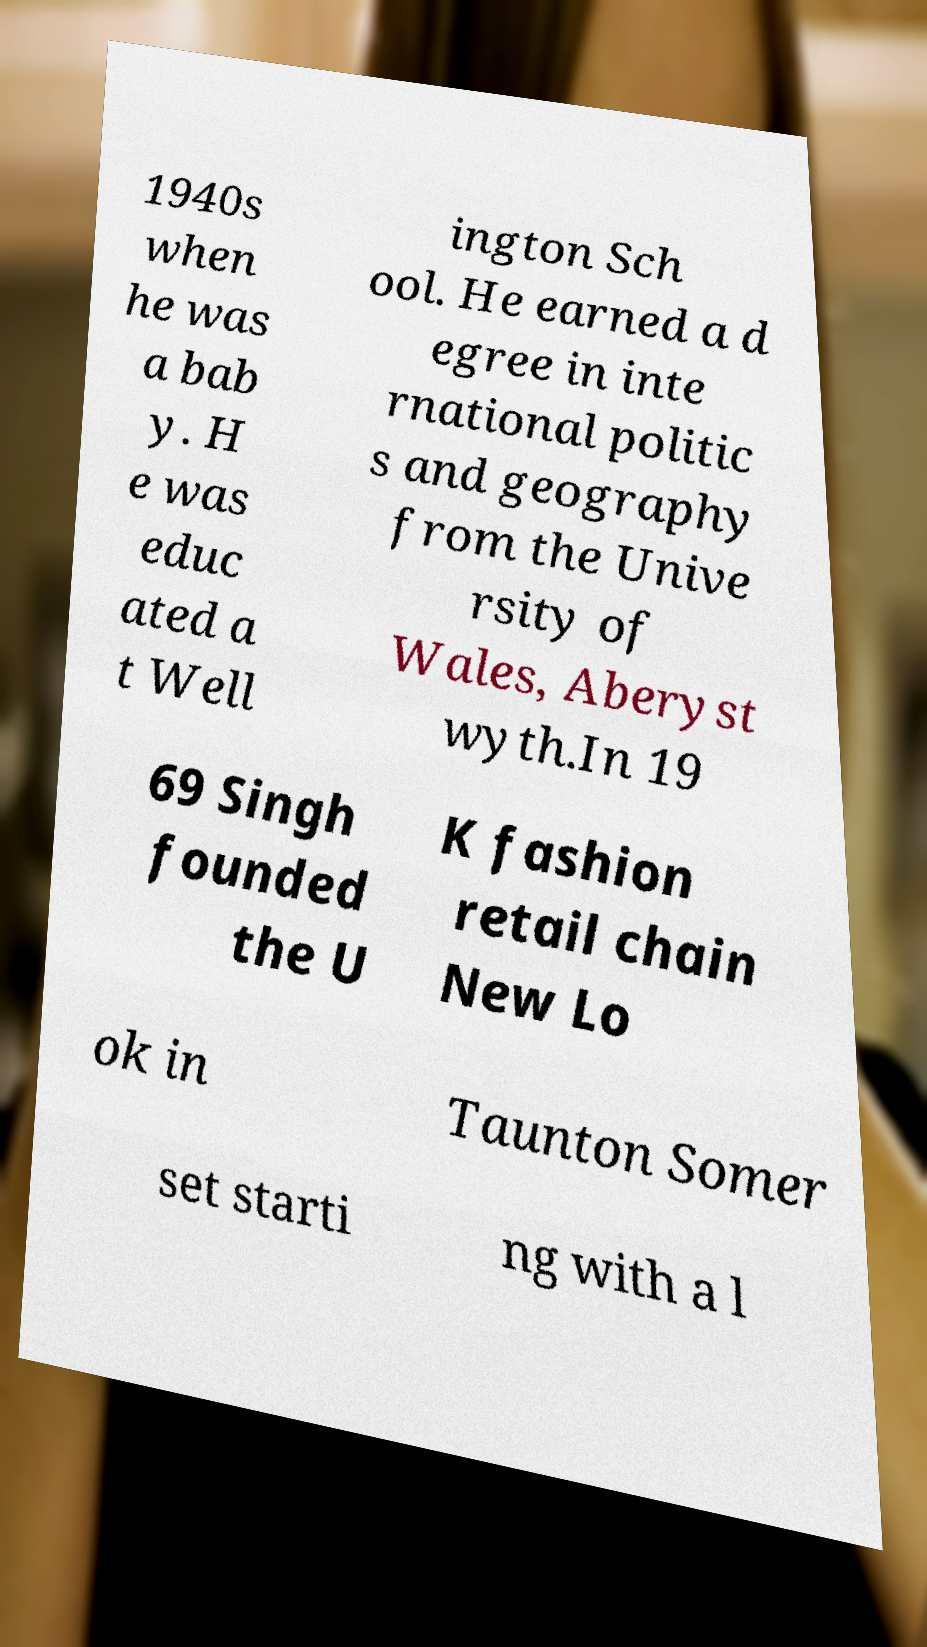For documentation purposes, I need the text within this image transcribed. Could you provide that? 1940s when he was a bab y. H e was educ ated a t Well ington Sch ool. He earned a d egree in inte rnational politic s and geography from the Unive rsity of Wales, Aberyst wyth.In 19 69 Singh founded the U K fashion retail chain New Lo ok in Taunton Somer set starti ng with a l 